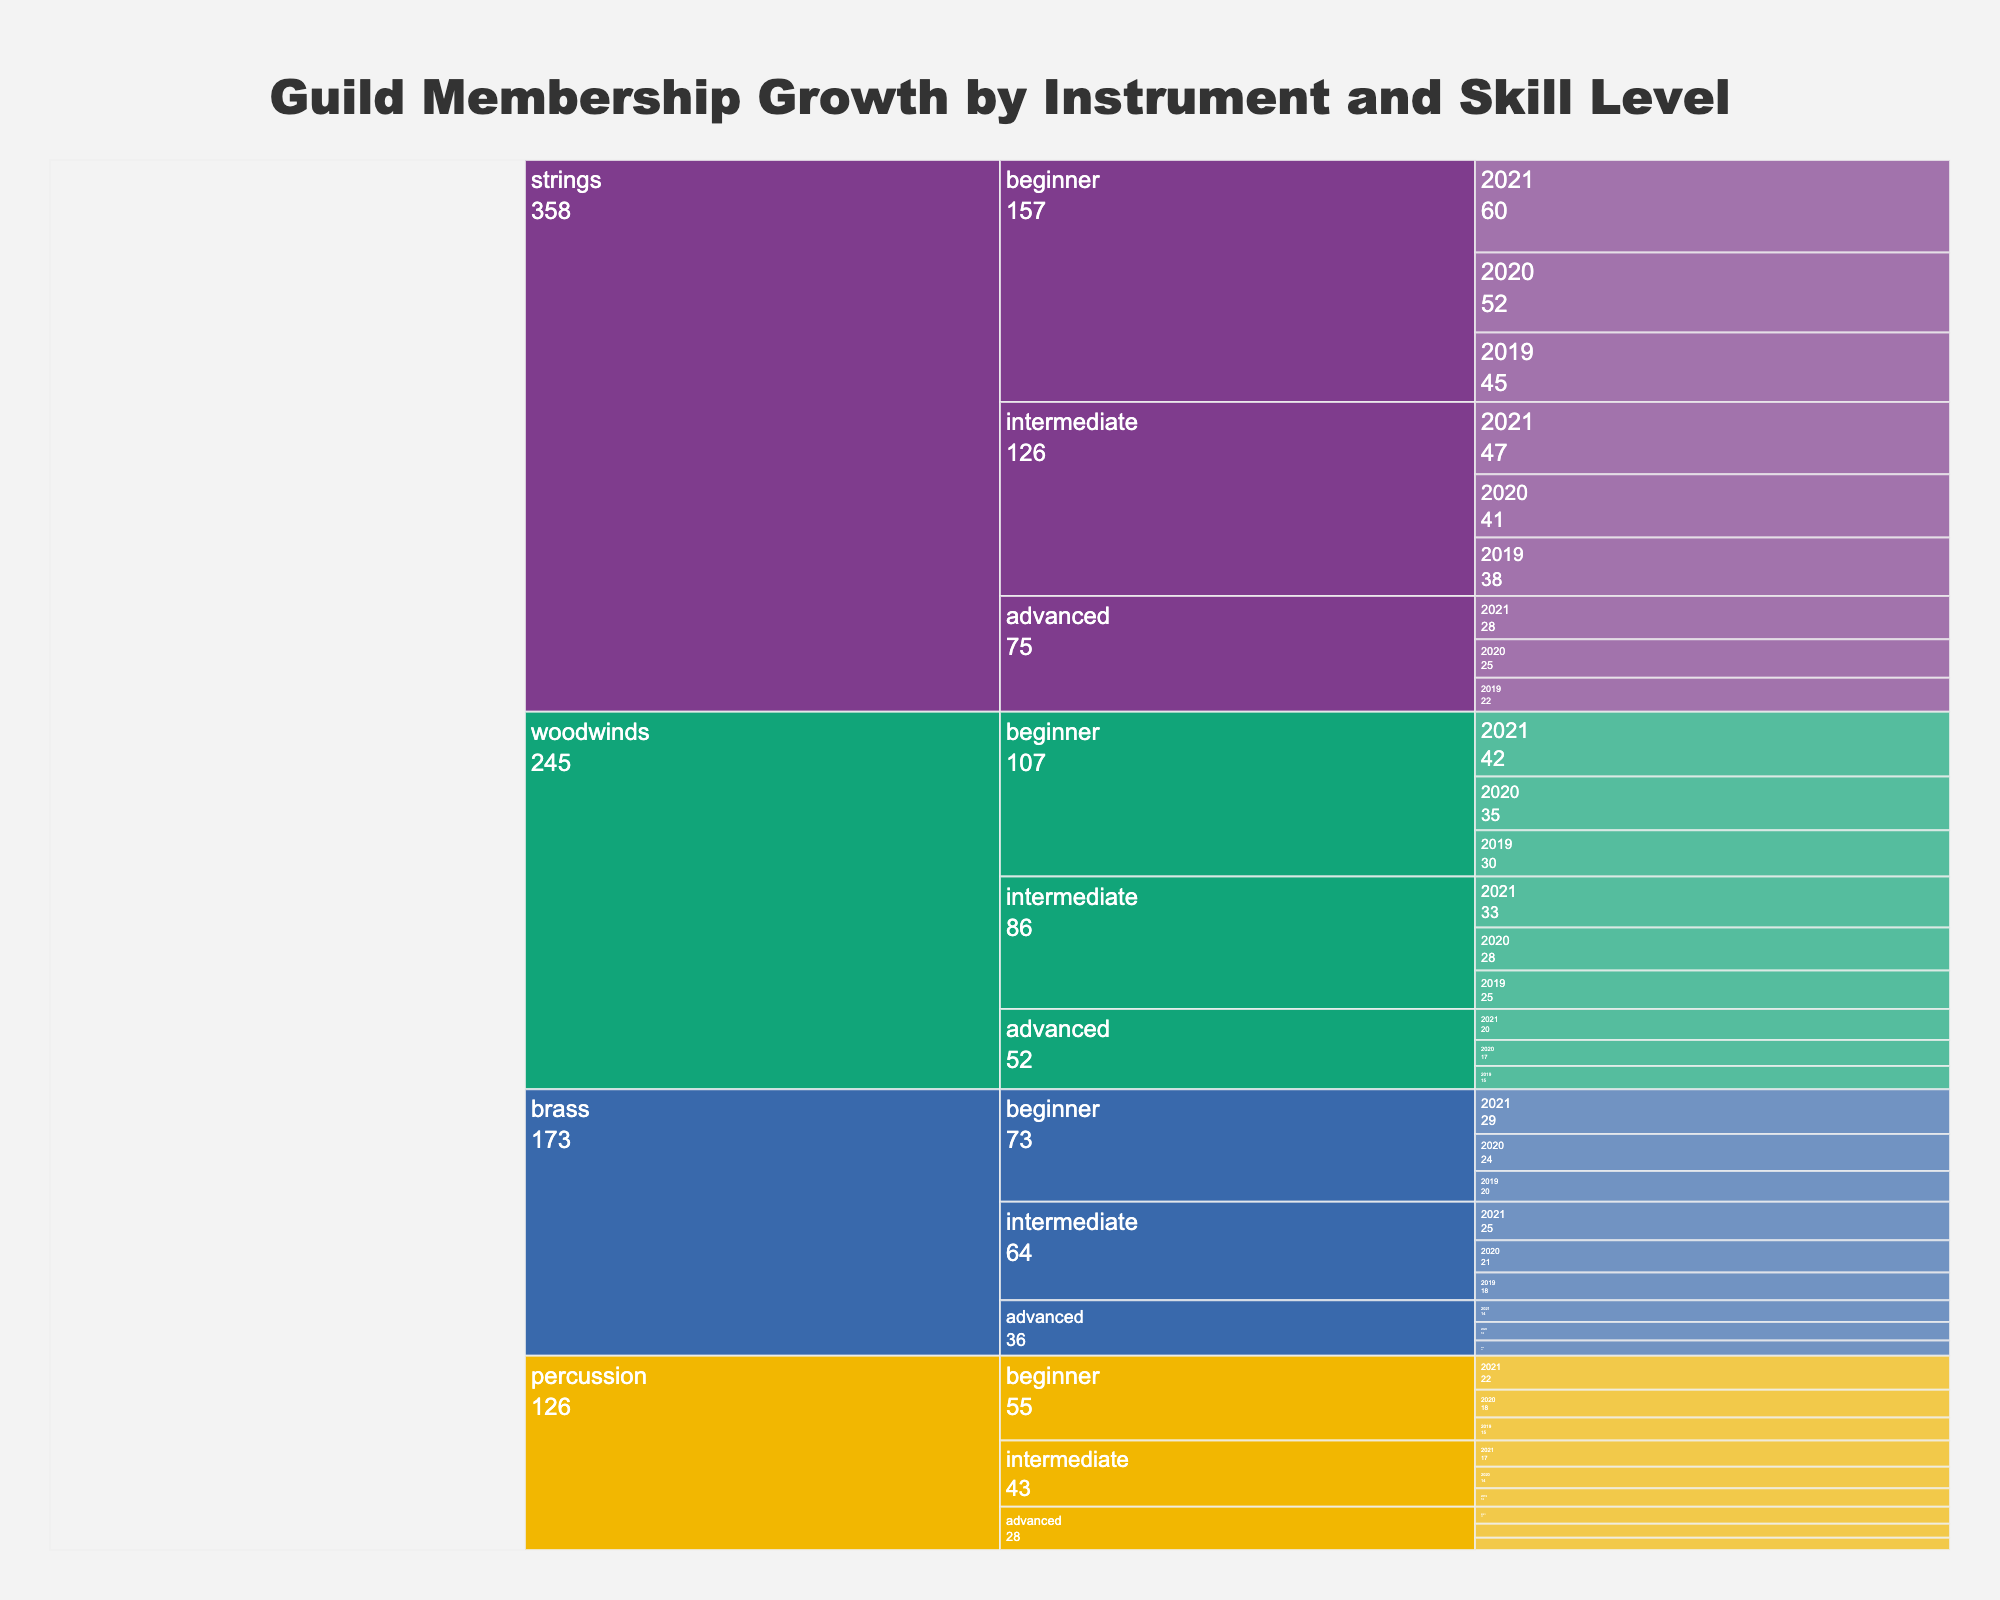what is the title of the icicle chart? The title is usually found at the top center of the figure. In this case, it reads "Guild Membership Growth by Instrument and Skill Level".
Answer: Guild Membership Growth by Instrument and Skill Level What instrument category has the most members in 2021? Check all the instrument categories for the year 2021 and identify which has the highest number of members. Strings category for 2021 shows the highest members (beginner, intermediate, and advanced combined).
Answer: Strings How many members were advanced brass players in 2020? Locate the section corresponding to brass players for 2020 and then focus on the advanced skill level. It shows 12 members.
Answer: 12 Compare the membership growth of beginner woodwinds players from 2019 to 2021. Look at the number of beginner woodwinds members for 2019, 2020, and 2021 and observe the trend. It grows from 30 in 2019 to 35 in 2020 and 42 in 2021.
Answer: Increased Which skill level within the strings category had the least members in 2019? In the strings category for 2019, compare the number of beginner, intermediate, and advanced members. The advanced level has the least with 22 members.
Answer: Advanced What is the average number of intermediate woodwinds players from 2019 to 2021? Sum the number of intermediate woodwinds members for the years 2019 (25), 2020 (28), and 2021 (33), then divide by 3. (25+28+33)/3 = 86/3 = 28.67
Answer: 28.67 Which year had the highest total membership across all categories? Sum up the total memberships across all categories for each year and compare. 2019: 293, 2020: 329, 2021: 388. Hence, 2021 had the highest.
Answer: 2021 By how much did advanced percussion players increase from 2019 to 2021? Subtract the number of advanced percussion players in 2019 (8) from the number in 2021 (11). 11 - 8 = 3
Answer: 3 Which instrument skill level saw the highest increase in membership from 2019 to 2021? Calculate the increase in each skill level within each instrument category from 2019 to 2021, and identify the highest one. Beginner strings increased the most from 45 to 60, which is an increase of 15 members.
Answer: Beginner Strings Which category had more members in 2021: intermediate brass or advanced woodwinds? Compare the membership numbers for intermediate brass (25) and advanced woodwinds (20) in 2021. Intermediate brass has more members.
Answer: Intermediate Brass 